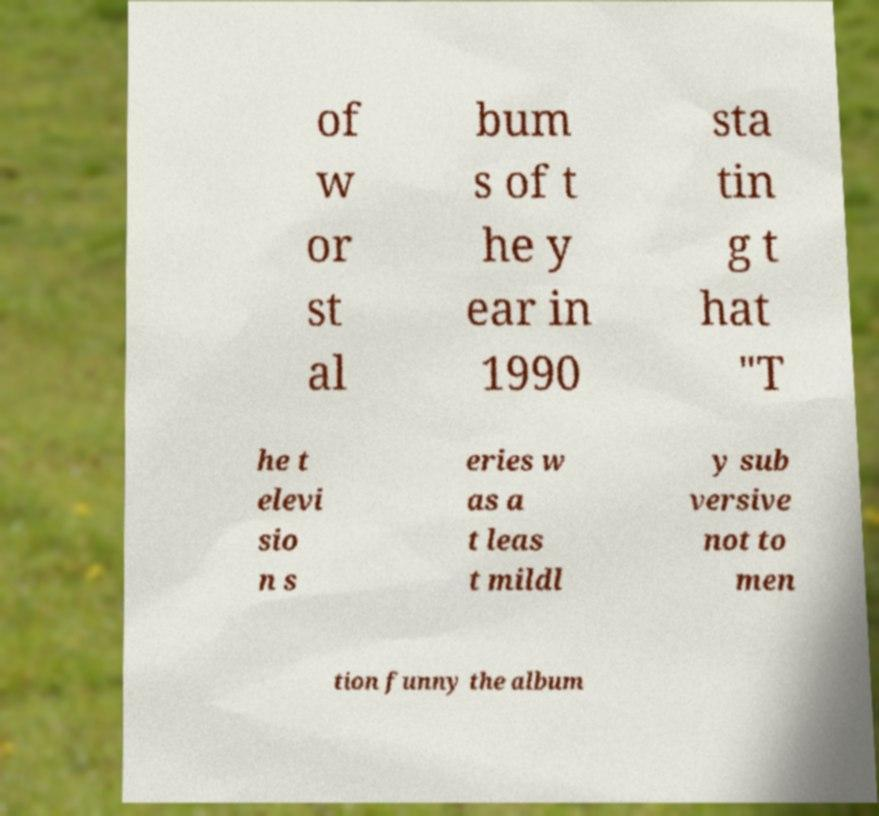Can you read and provide the text displayed in the image?This photo seems to have some interesting text. Can you extract and type it out for me? of w or st al bum s of t he y ear in 1990 sta tin g t hat "T he t elevi sio n s eries w as a t leas t mildl y sub versive not to men tion funny the album 